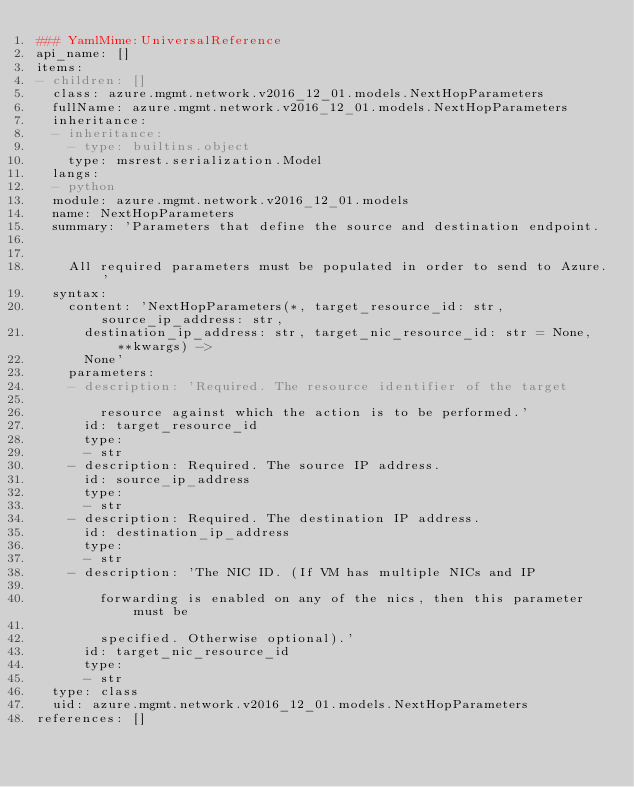Convert code to text. <code><loc_0><loc_0><loc_500><loc_500><_YAML_>### YamlMime:UniversalReference
api_name: []
items:
- children: []
  class: azure.mgmt.network.v2016_12_01.models.NextHopParameters
  fullName: azure.mgmt.network.v2016_12_01.models.NextHopParameters
  inheritance:
  - inheritance:
    - type: builtins.object
    type: msrest.serialization.Model
  langs:
  - python
  module: azure.mgmt.network.v2016_12_01.models
  name: NextHopParameters
  summary: 'Parameters that define the source and destination endpoint.


    All required parameters must be populated in order to send to Azure.'
  syntax:
    content: 'NextHopParameters(*, target_resource_id: str, source_ip_address: str,
      destination_ip_address: str, target_nic_resource_id: str = None, **kwargs) ->
      None'
    parameters:
    - description: 'Required. The resource identifier of the target

        resource against which the action is to be performed.'
      id: target_resource_id
      type:
      - str
    - description: Required. The source IP address.
      id: source_ip_address
      type:
      - str
    - description: Required. The destination IP address.
      id: destination_ip_address
      type:
      - str
    - description: 'The NIC ID. (If VM has multiple NICs and IP

        forwarding is enabled on any of the nics, then this parameter must be

        specified. Otherwise optional).'
      id: target_nic_resource_id
      type:
      - str
  type: class
  uid: azure.mgmt.network.v2016_12_01.models.NextHopParameters
references: []
</code> 